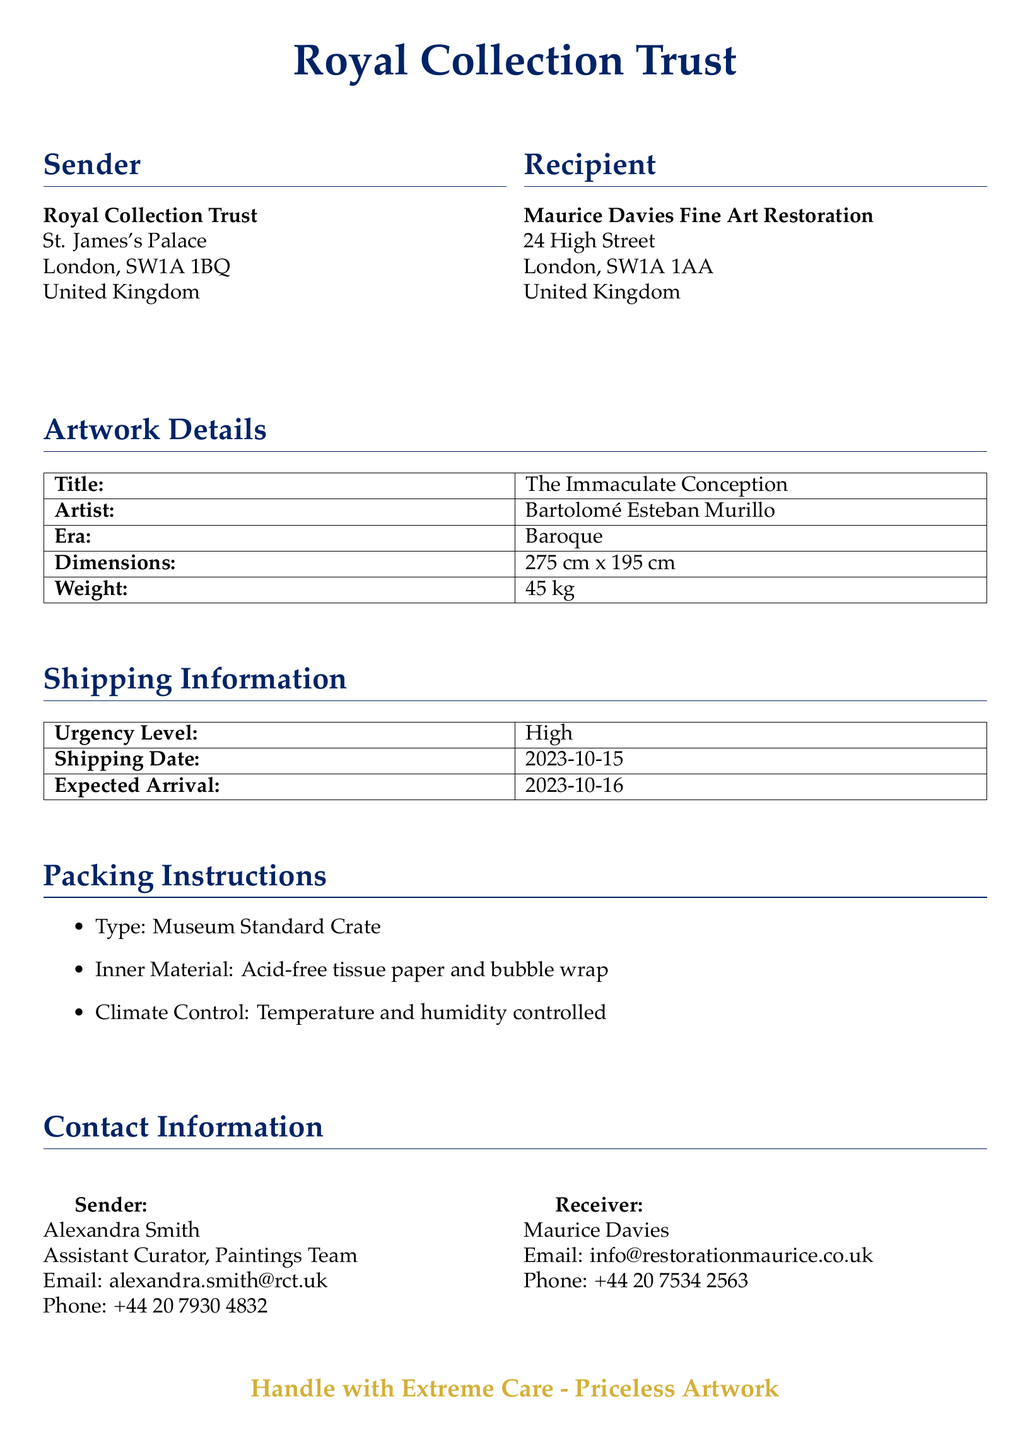what is the title of the artwork? The title of the artwork is mentioned in the artwork details section of the document.
Answer: The Immaculate Conception who is the artist of the painting? The artist's name is provided in the artwork details section.
Answer: Bartolomé Esteban Murillo what are the dimensions of the painting? The dimensions are stated directly in the artwork details section.
Answer: 275 cm x 195 cm what is the weight of the painting? The weight is specified in the artwork details section.
Answer: 45 kg what is the urgency level for shipping? The urgency level is clearly outlined in the shipping information section of the document.
Answer: High what is the expected arrival date? The expected arrival date is indicated in the shipping information section.
Answer: 2023-10-16 how is the artwork packed? The packing instructions describe how the artwork will be packaged for shipping.
Answer: Museum Standard Crate who is the sender of the artwork? The sender's details are provided in the sender section of the document.
Answer: Royal Collection Trust what is the shipping date? The shipping date is stated in the shipping information section of the document.
Answer: 2023-10-15 what type of crate is used for shipping? The type of crate is listed in the packing instructions section.
Answer: Museum Standard Crate 